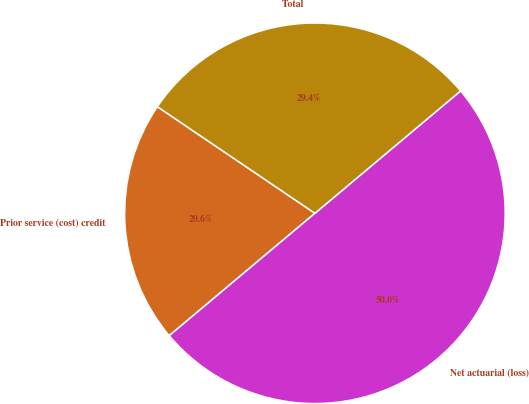Convert chart. <chart><loc_0><loc_0><loc_500><loc_500><pie_chart><fcel>Prior service (cost) credit<fcel>Net actuarial (loss)<fcel>Total<nl><fcel>20.59%<fcel>50.0%<fcel>29.41%<nl></chart> 